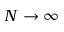Convert formula to latex. <formula><loc_0><loc_0><loc_500><loc_500>N \rightarrow \infty</formula> 